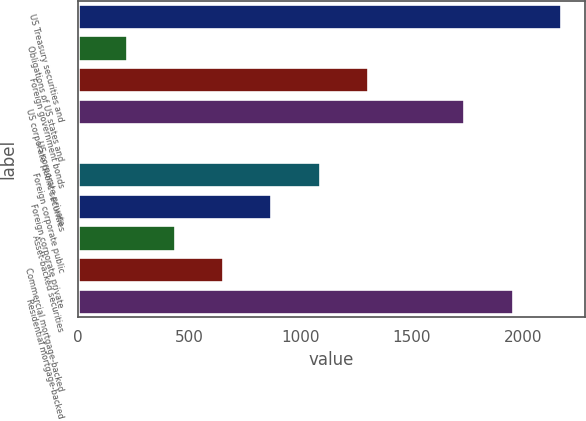<chart> <loc_0><loc_0><loc_500><loc_500><bar_chart><fcel>US Treasury securities and<fcel>Obligations of US states and<fcel>Foreign government bonds<fcel>US corporate public securities<fcel>US corporate private<fcel>Foreign corporate public<fcel>Foreign corporate private<fcel>Asset-backed securities<fcel>Commercial mortgage-backed<fcel>Residential mortgage-backed<nl><fcel>2170.98<fcel>218.16<fcel>1303.06<fcel>1737.02<fcel>1.18<fcel>1086.08<fcel>869.1<fcel>435.14<fcel>652.12<fcel>1954<nl></chart> 